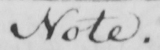What is written in this line of handwriting? Note . 